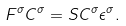<formula> <loc_0><loc_0><loc_500><loc_500>F ^ { \sigma } C ^ { \sigma } = S C ^ { \sigma } \epsilon ^ { \sigma } .</formula> 